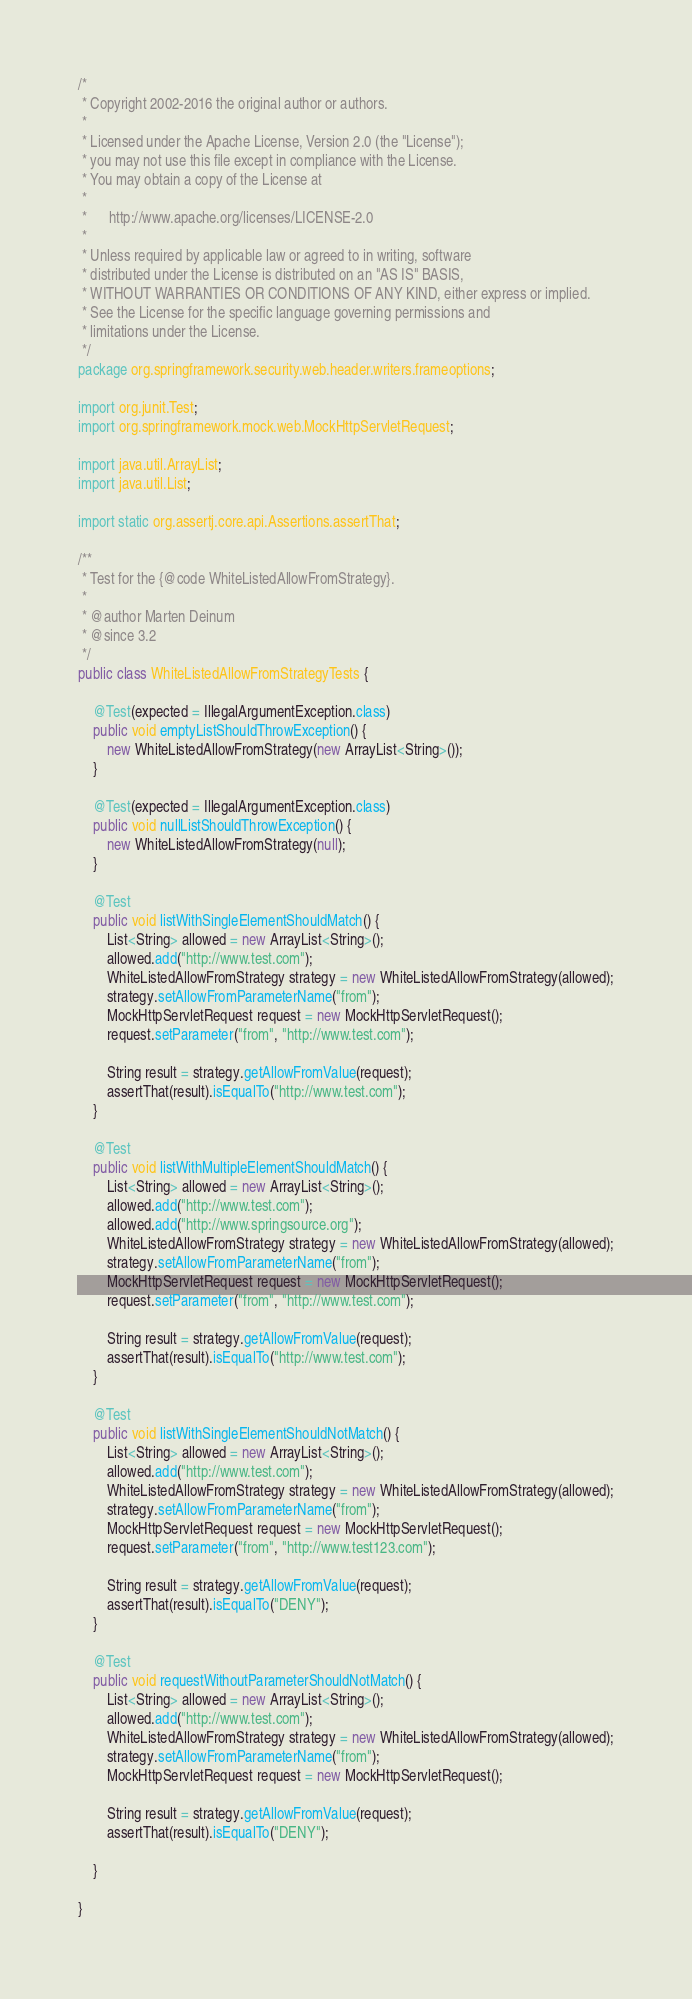Convert code to text. <code><loc_0><loc_0><loc_500><loc_500><_Java_>/*
 * Copyright 2002-2016 the original author or authors.
 *
 * Licensed under the Apache License, Version 2.0 (the "License");
 * you may not use this file except in compliance with the License.
 * You may obtain a copy of the License at
 *
 *      http://www.apache.org/licenses/LICENSE-2.0
 *
 * Unless required by applicable law or agreed to in writing, software
 * distributed under the License is distributed on an "AS IS" BASIS,
 * WITHOUT WARRANTIES OR CONDITIONS OF ANY KIND, either express or implied.
 * See the License for the specific language governing permissions and
 * limitations under the License.
 */
package org.springframework.security.web.header.writers.frameoptions;

import org.junit.Test;
import org.springframework.mock.web.MockHttpServletRequest;

import java.util.ArrayList;
import java.util.List;

import static org.assertj.core.api.Assertions.assertThat;

/**
 * Test for the {@code WhiteListedAllowFromStrategy}.
 *
 * @author Marten Deinum
 * @since 3.2
 */
public class WhiteListedAllowFromStrategyTests {

	@Test(expected = IllegalArgumentException.class)
	public void emptyListShouldThrowException() {
		new WhiteListedAllowFromStrategy(new ArrayList<String>());
	}

	@Test(expected = IllegalArgumentException.class)
	public void nullListShouldThrowException() {
		new WhiteListedAllowFromStrategy(null);
	}

	@Test
	public void listWithSingleElementShouldMatch() {
		List<String> allowed = new ArrayList<String>();
		allowed.add("http://www.test.com");
		WhiteListedAllowFromStrategy strategy = new WhiteListedAllowFromStrategy(allowed);
		strategy.setAllowFromParameterName("from");
		MockHttpServletRequest request = new MockHttpServletRequest();
		request.setParameter("from", "http://www.test.com");

		String result = strategy.getAllowFromValue(request);
		assertThat(result).isEqualTo("http://www.test.com");
	}

	@Test
	public void listWithMultipleElementShouldMatch() {
		List<String> allowed = new ArrayList<String>();
		allowed.add("http://www.test.com");
		allowed.add("http://www.springsource.org");
		WhiteListedAllowFromStrategy strategy = new WhiteListedAllowFromStrategy(allowed);
		strategy.setAllowFromParameterName("from");
		MockHttpServletRequest request = new MockHttpServletRequest();
		request.setParameter("from", "http://www.test.com");

		String result = strategy.getAllowFromValue(request);
		assertThat(result).isEqualTo("http://www.test.com");
	}

	@Test
	public void listWithSingleElementShouldNotMatch() {
		List<String> allowed = new ArrayList<String>();
		allowed.add("http://www.test.com");
		WhiteListedAllowFromStrategy strategy = new WhiteListedAllowFromStrategy(allowed);
		strategy.setAllowFromParameterName("from");
		MockHttpServletRequest request = new MockHttpServletRequest();
		request.setParameter("from", "http://www.test123.com");

		String result = strategy.getAllowFromValue(request);
		assertThat(result).isEqualTo("DENY");
	}

	@Test
	public void requestWithoutParameterShouldNotMatch() {
		List<String> allowed = new ArrayList<String>();
		allowed.add("http://www.test.com");
		WhiteListedAllowFromStrategy strategy = new WhiteListedAllowFromStrategy(allowed);
		strategy.setAllowFromParameterName("from");
		MockHttpServletRequest request = new MockHttpServletRequest();

		String result = strategy.getAllowFromValue(request);
		assertThat(result).isEqualTo("DENY");

	}

}
</code> 